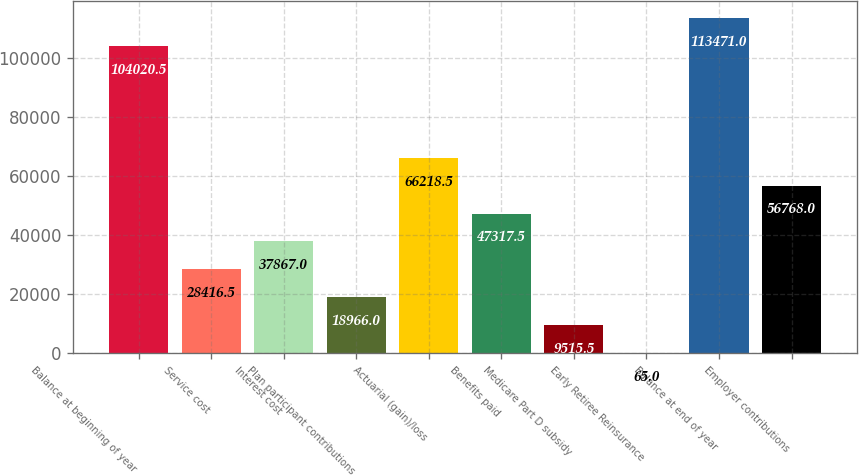Convert chart to OTSL. <chart><loc_0><loc_0><loc_500><loc_500><bar_chart><fcel>Balance at beginning of year<fcel>Service cost<fcel>Interest cost<fcel>Plan participant contributions<fcel>Actuarial (gain)/loss<fcel>Benefits paid<fcel>Medicare Part D subsidy<fcel>Early Retiree Reinsurance<fcel>Balance at end of year<fcel>Employer contributions<nl><fcel>104020<fcel>28416.5<fcel>37867<fcel>18966<fcel>66218.5<fcel>47317.5<fcel>9515.5<fcel>65<fcel>113471<fcel>56768<nl></chart> 